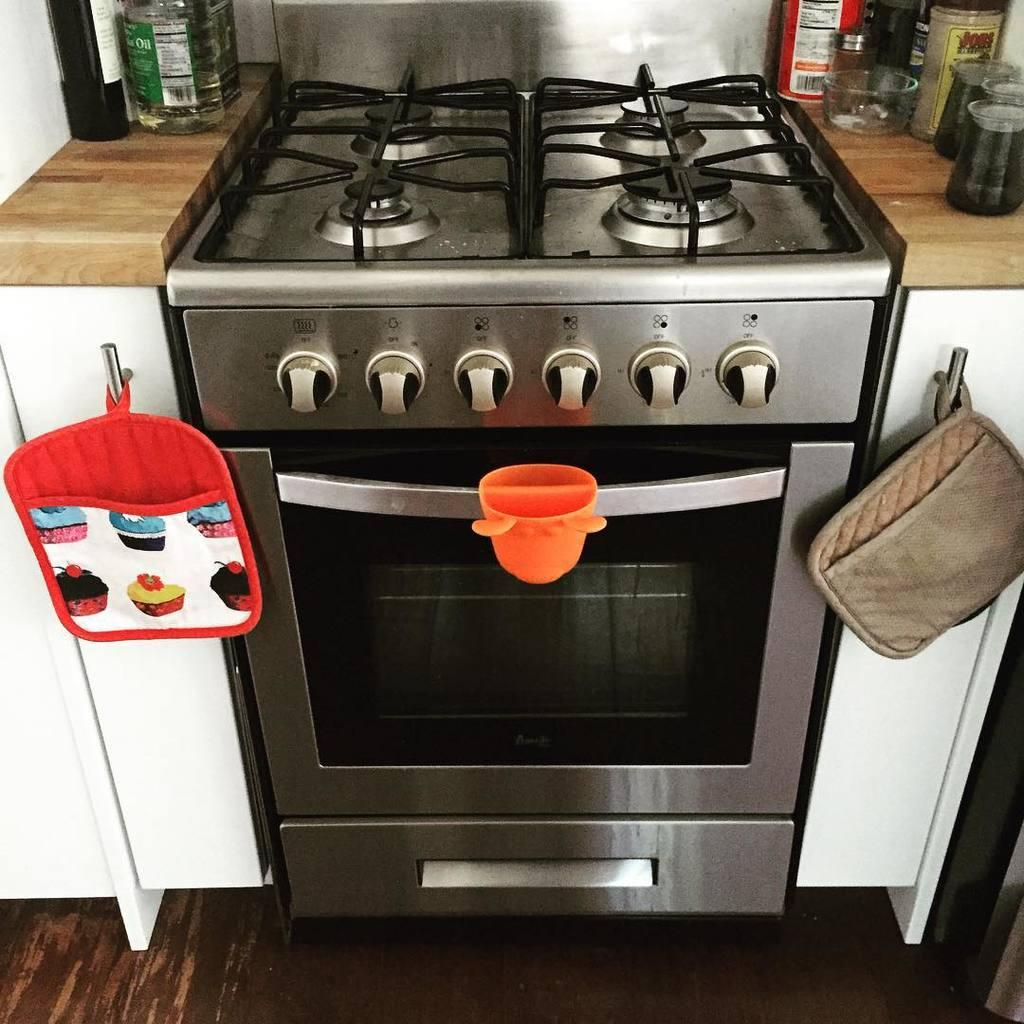What type of room is shown in the image? The image shows a kitchen view. What cooking appliance can be seen in the kitchen? There is a stove in the kitchen. What type of containers are present in the kitchen? Glass jars are present in the kitchen. What other cooking appliance can be seen in the kitchen? There is a microwave oven in the kitchen. What other objects can be seen in the kitchen? There are additional objects visible in the kitchen. Where is the patch located on the stove in the image? There is no patch present on the stove in the image. What type of jewelry can be seen hanging from the microwave oven in the image? There is no jewelry, such as a locket, present in the image. 